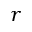Convert formula to latex. <formula><loc_0><loc_0><loc_500><loc_500>r</formula> 